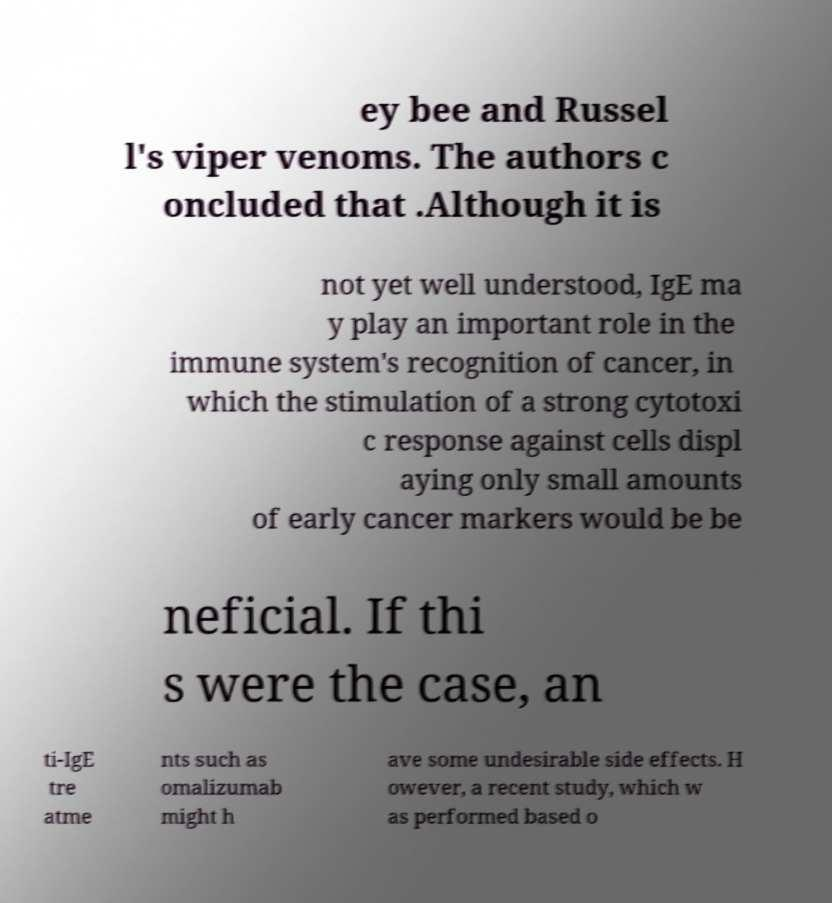Can you read and provide the text displayed in the image?This photo seems to have some interesting text. Can you extract and type it out for me? ey bee and Russel l's viper venoms. The authors c oncluded that .Although it is not yet well understood, IgE ma y play an important role in the immune system's recognition of cancer, in which the stimulation of a strong cytotoxi c response against cells displ aying only small amounts of early cancer markers would be be neficial. If thi s were the case, an ti-IgE tre atme nts such as omalizumab might h ave some undesirable side effects. H owever, a recent study, which w as performed based o 